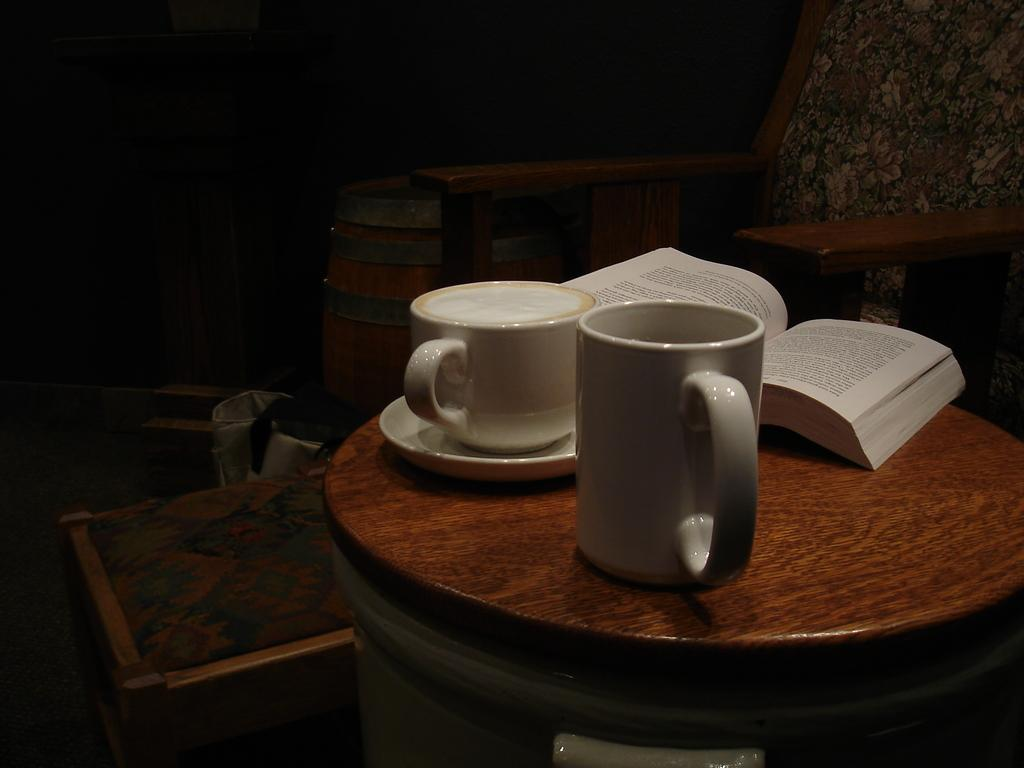What type of furniture is present in the image? There is a table, a stool, and a chair in the image. Where is the chair located in the image? The chair is in the top right corner of the image. What items are on the table in the image? There is a cup, a saucer, and a book on the table in the image. What type of pollution can be seen in the image? There is no pollution visible in the image; it only features furniture and items on a table. How many toes are visible in the image? There are no visible toes in the image. 